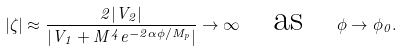<formula> <loc_0><loc_0><loc_500><loc_500>| \zeta | \approx \frac { 2 | V _ { 2 } | } { | V _ { 1 } + M ^ { 4 } e ^ { - 2 \alpha \phi / M _ { p } } | } \rightarrow \infty \quad \text {as} \quad \phi \rightarrow \phi _ { 0 } .</formula> 